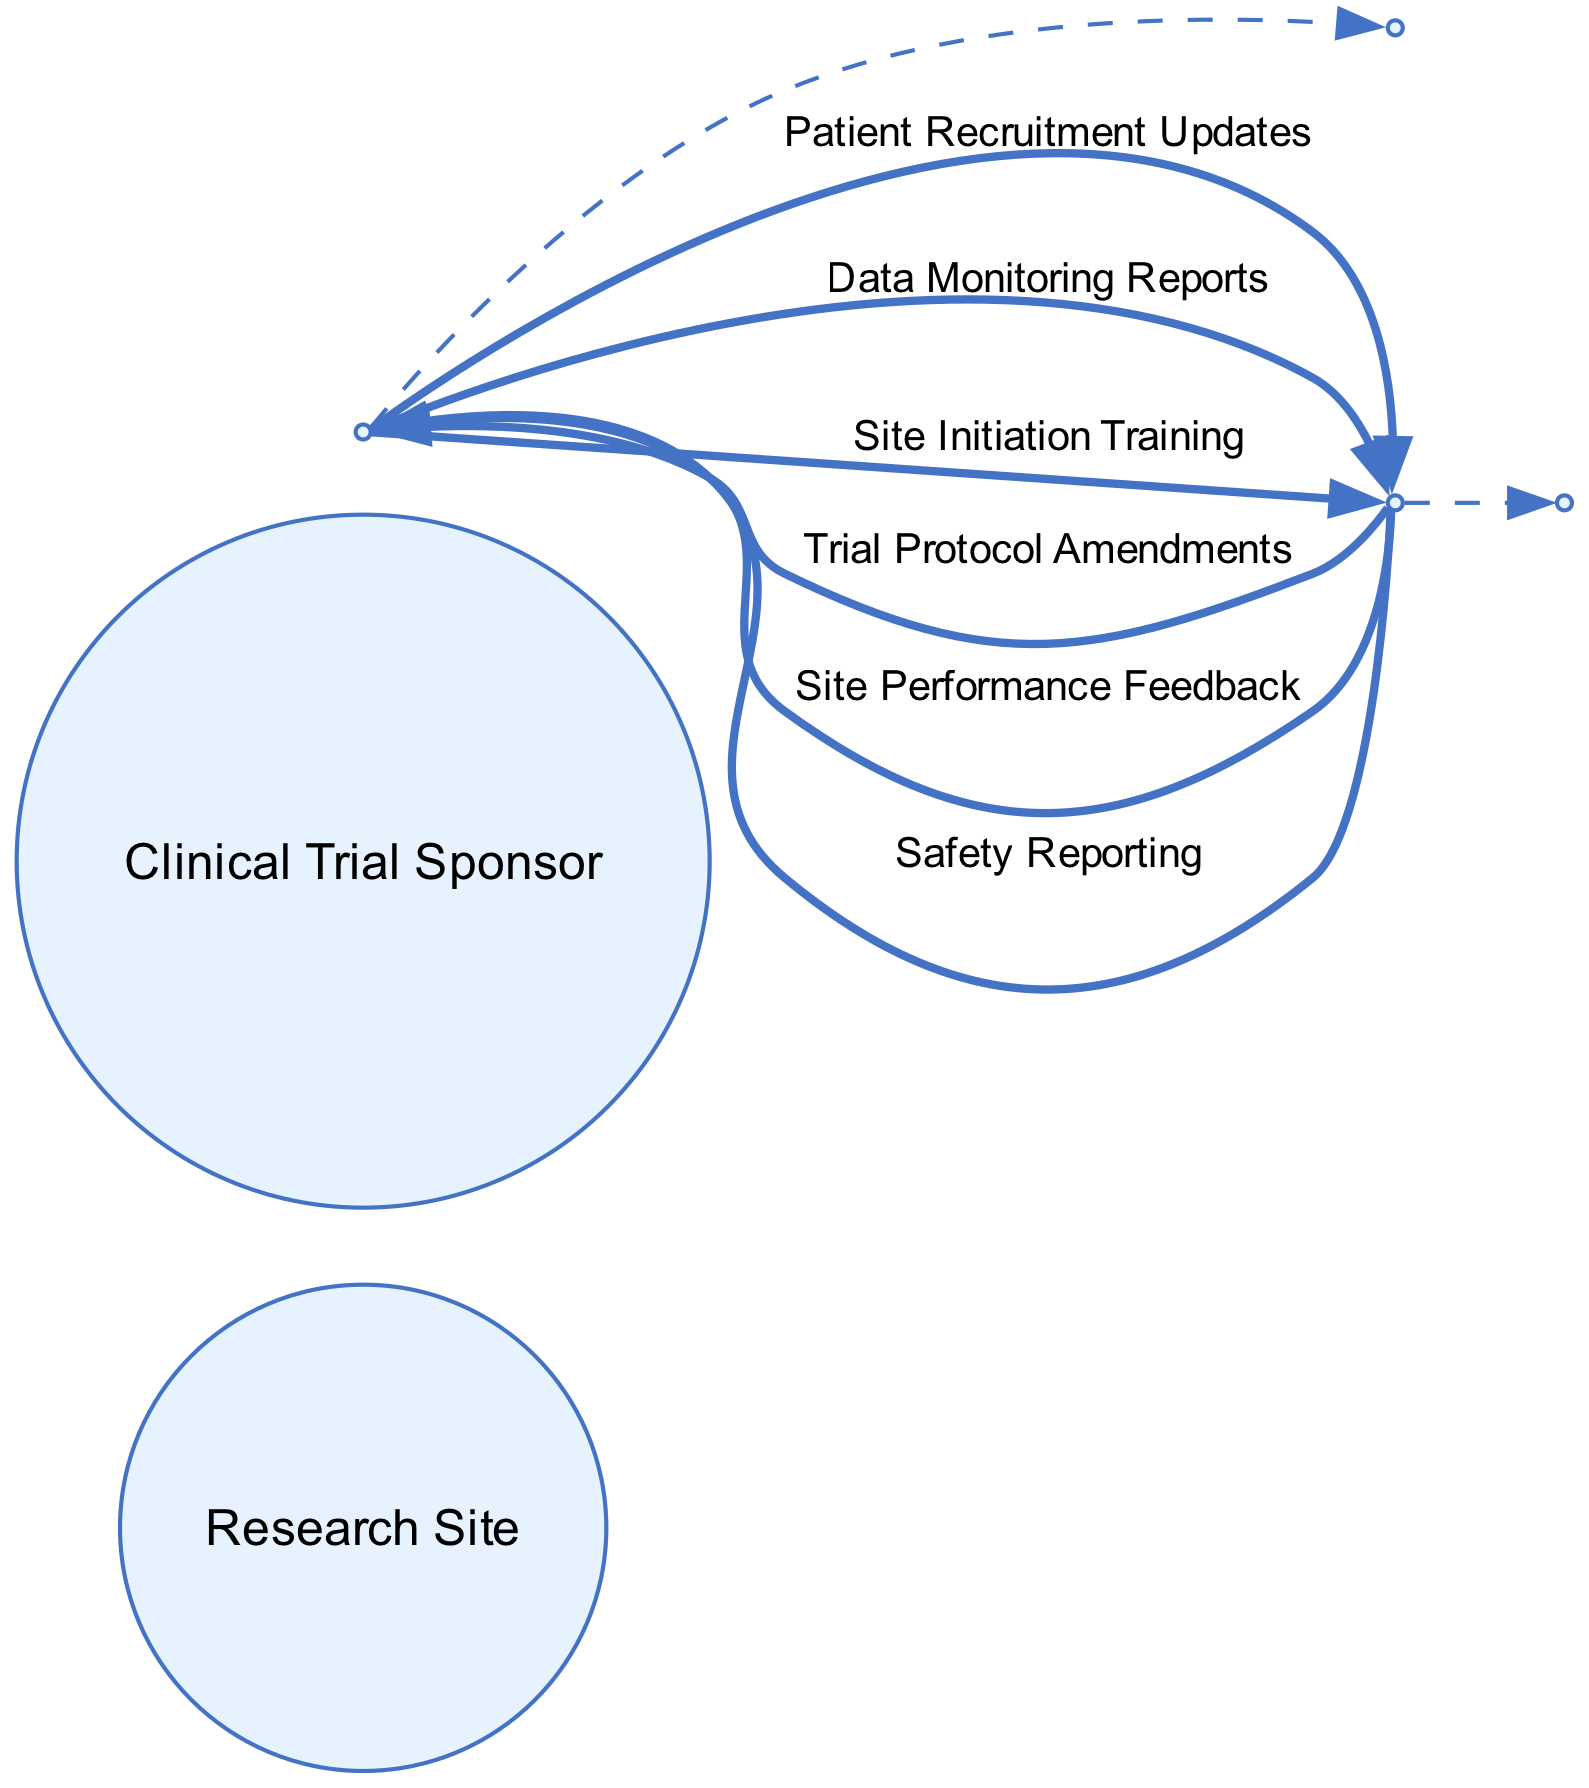What are the two primary actors in the diagram? The diagram displays two main actors: the Research Site and the Clinical Trial Sponsor. Both are clearly labeled as actors in the sequence diagram.
Answer: Research Site, Clinical Trial Sponsor How many messages are exchanged between the actors? The diagram includes a total of six messages that are exchanged between the Research Site and the Clinical Trial Sponsor. These are depicted as arrows between the two actors.
Answer: six What type of message is sent first from the Research Site? The first message sent from the Research Site in the sequence is the Patient Recruitment Updates, which can be identified as the topmost outgoing arrow.
Answer: Patient Recruitment Updates Which message is sent in response to the Data Monitoring Reports? Following the Data Monitoring Reports, the next message sent back is the Site Performance Feedback. This can be traced by following the arrows in the diagram in the order they are presented.
Answer: Site Performance Feedback What is the order of messages sent from the Clinical Trial Sponsor to the Research Site? The sequence of messages from the Clinical Trial Sponsor to the Research Site includes: Trial Protocol Amendments, Site Initiation Training, and Safety Reporting, in that order, as observed through the arrows indicating the direction of communication flow.
Answer: Trial Protocol Amendments, Site Initiation Training, Safety Reporting How does the diagram facilitate understanding of communication flow in clinical trials? The diagram provides a clear visual representation of the sequential communication occurring between the Research Site and the Clinical Trial Sponsor, illustrating both the types of messages and their order, which enhances comprehension of the typical workflow in clinical trial interactions.
Answer: It visualizes sequential communication 